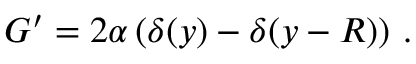Convert formula to latex. <formula><loc_0><loc_0><loc_500><loc_500>G ^ { \prime } = 2 \alpha \left ( \delta ( y ) - \delta ( y - R ) \right ) \, .</formula> 